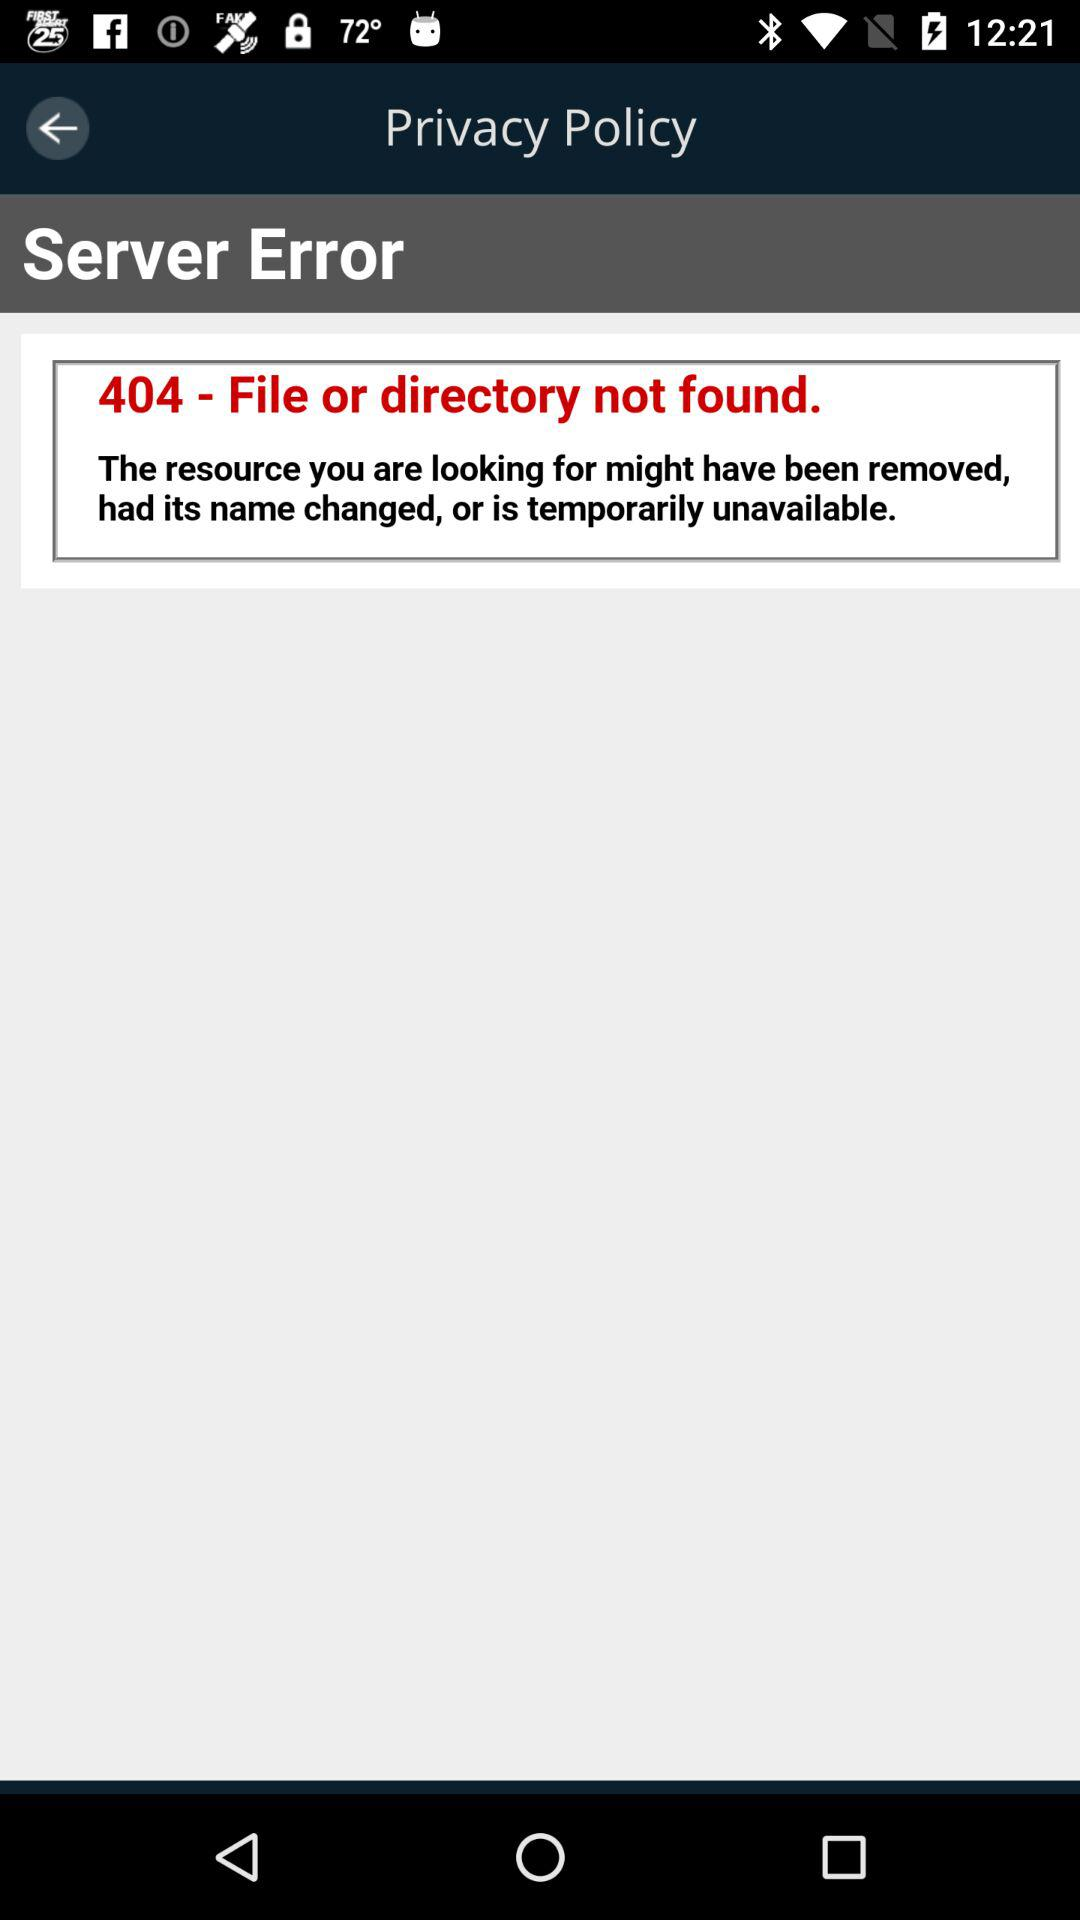What is the error name? The error name is 404. 